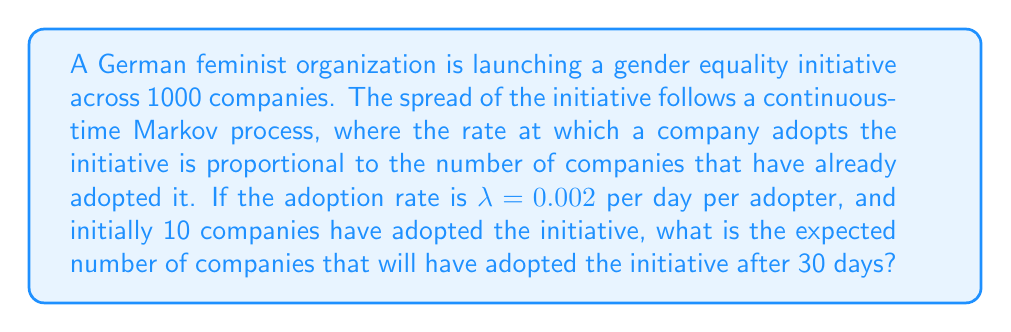Can you solve this math problem? To solve this problem, we can use the logistic growth model, which is a type of continuous-time Markov process often used to model the spread of innovations or ideas in a population.

Let $X(t)$ be the number of companies that have adopted the initiative at time $t$.

1) The differential equation for this model is:

   $$\frac{dX}{dt} = \lambda X(t)(N - X(t))$$

   where $N$ is the total population (1000 companies) and $\lambda$ is the adoption rate (0.002 per day per adopter).

2) The solution to this differential equation is:

   $$X(t) = \frac{N}{1 + (\frac{N}{X_0} - 1)e^{-\lambda Nt}}$$

   where $X_0$ is the initial number of adopters (10 companies).

3) Plugging in our values:

   $$X(30) = \frac{1000}{1 + (\frac{1000}{10} - 1)e^{-0.002 \cdot 1000 \cdot 30}}$$

4) Simplify:

   $$X(30) = \frac{1000}{1 + 99e^{-60}}$$

5) Calculate:

   $$X(30) \approx 403.43$$

6) Since we're dealing with whole companies, we round to the nearest integer.
Answer: 403 companies 